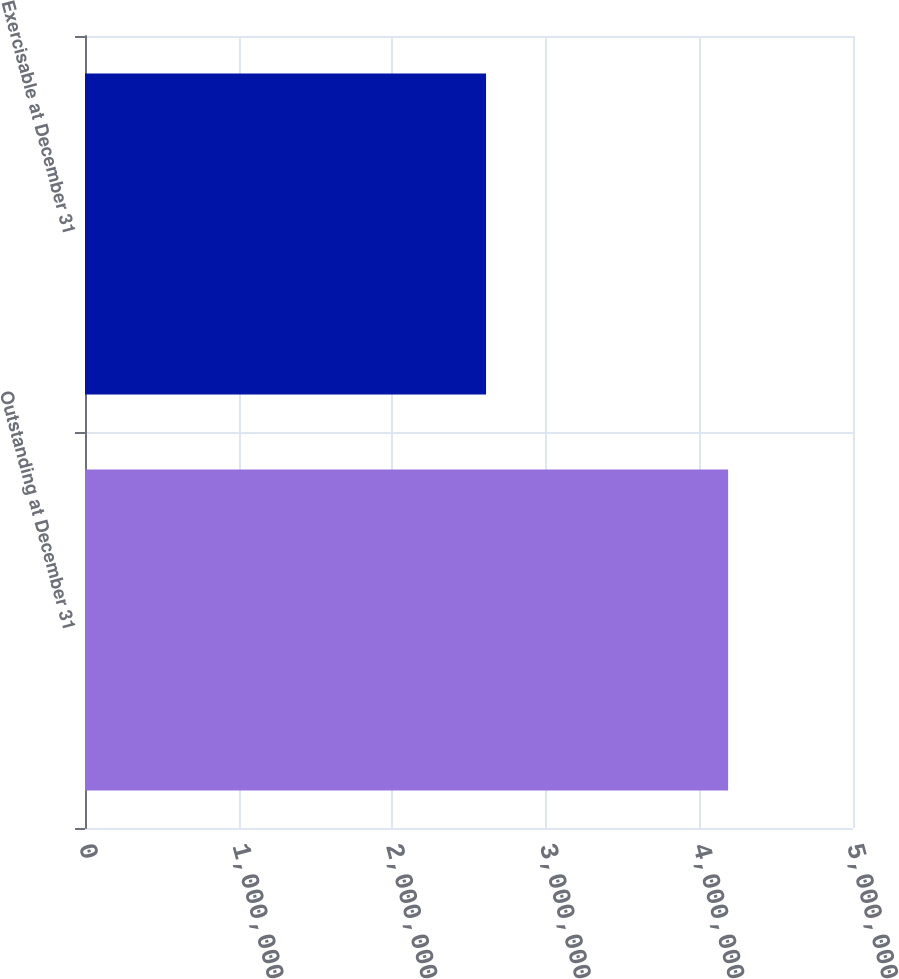<chart> <loc_0><loc_0><loc_500><loc_500><bar_chart><fcel>Outstanding at December 31<fcel>Exercisable at December 31<nl><fcel>4.187e+06<fcel>2.611e+06<nl></chart> 